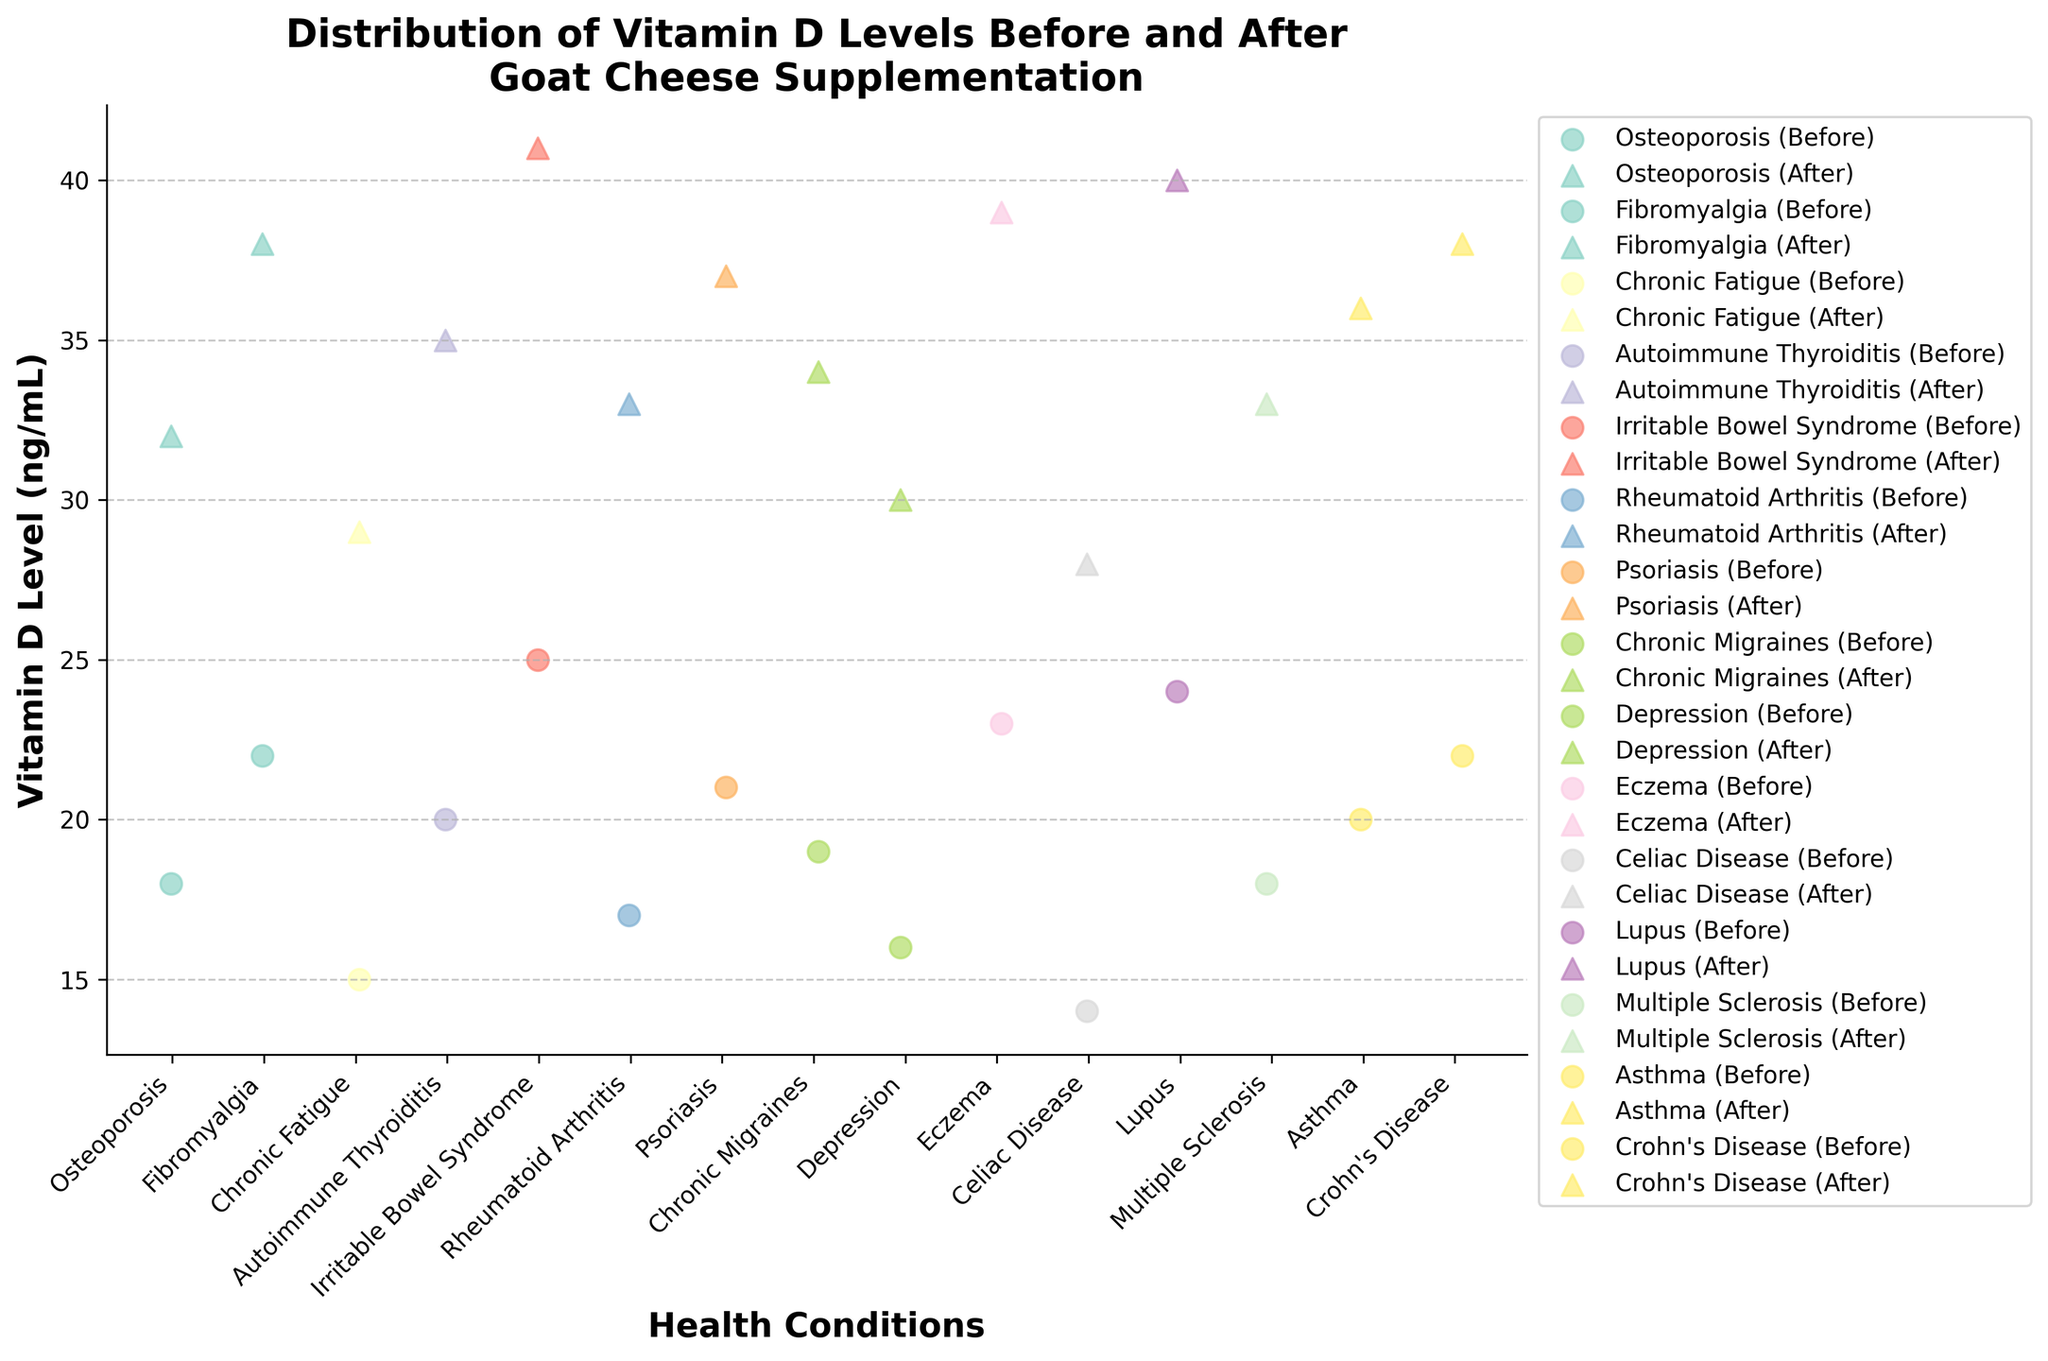what is the title of the figure? The title is usually placed at the top of the plot and provides a summary of what the plot is about. The title in this figure is “Distribution of Vitamin D Levels Before and After Goat Cheese Supplementation.”
Answer: Distribution of Vitamin D Levels Before and After Goat Cheese Supplementation What are the labels on the X and Y axes? X and Y axis labels are typically used to indicate what each axis represents. In this plot, the X-axis is labeled "Health Conditions," and the Y-axis is labeled "Vitamin D Level (ng/mL)."
Answer: Health Conditions, Vitamin D Level (ng/mL) Which health condition has the highest vitamin D level after goat cheese supplementation? By looking at the scatter points with the highest Y values, we find that "Irritable Bowel Syndrome" (Olivia Brown) has the highest vitamin D level after supplementation, which is 41 ng/mL.
Answer: Irritable Bowel Syndrome (Olivia Brown) What is the color scheme used for different health conditions? The colors of the scatter points represent different health conditions. These colors vary according to the unique conditions and help to differentiate them visually. Specific colors are not identified but are distinguishable.
Answer: Unique colors for different conditions How many health conditions have an average vitamin D level after supplementation greater than 35 ng/mL? To determine this, calculate the average vitamin D level after supplementation for each condition, then count how many conditions have an average greater than 35. From the data: Fibromyalgia, Irritable Bowel Syndrome, Eczema, and Lupus have average levels greater than 35 ng/mL.
Answer: 4 Which condition shows the biggest difference in vitamin D levels before and after supplementation? Calculate the difference between before and after supplementation for each condition and find the largest difference. "Irritable Bowel Syndrome" (Olivia Brown) shows the biggest difference, which is 41 - 25 = 16 ng/mL.
Answer: Irritable Bowel Syndrome (Olivia Brown) What is the range of vitamin D levels after supplementation for Psoriasis? To find the range, identify the highest and lowest vitamin D levels after supplementation for Psoriasis patients. For Emma Garcia with Psoriasis, the level is 37 ng/mL.
Answer: 37 ng/mL How many distinct markers are used in the plot? The plot uses different markers to distinguish between "Before" and "After" vitamin D levels. By counting markers, we find circles and triangles are used.
Answer: 2 Which health condition had the least change in vitamin D levels after supplementation? Calculate the change in vitamin D levels for each condition and find the smallest difference. "Celiac Disease" (Ava Thompson) shows the smallest change, which is 28 - 14 = 14 ng/mL.
Answer: Celiac Disease (Ava Thompson) 